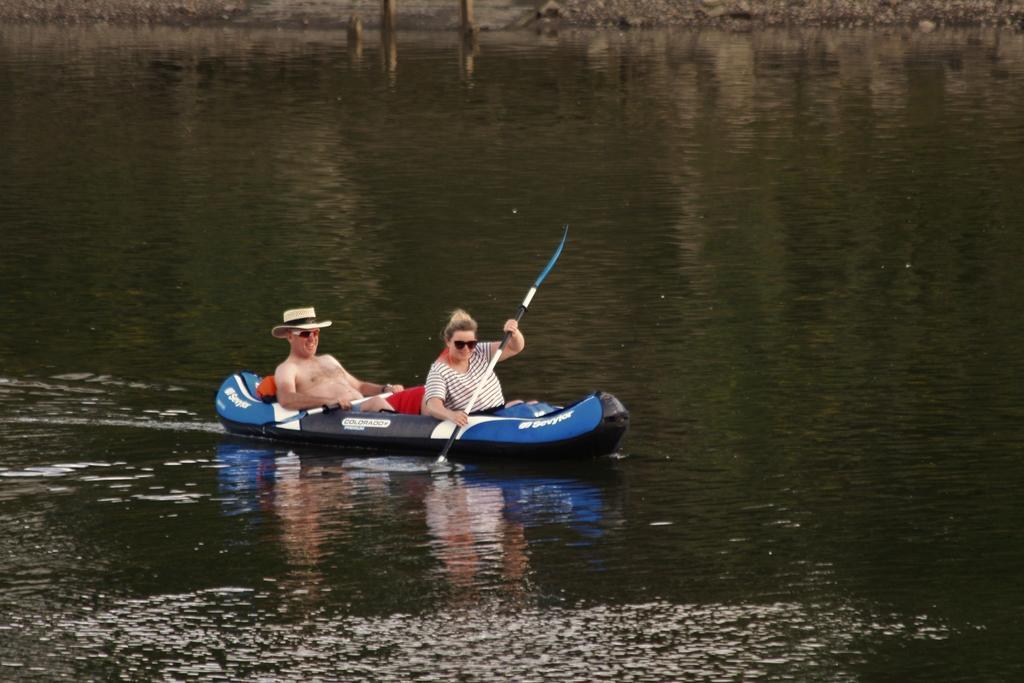Could you give a brief overview of what you see in this image? In the center of the image we can see two persons are sitting in the boat and they are holding paddles. And the man wearing a hat. In the background we can see water etc. 